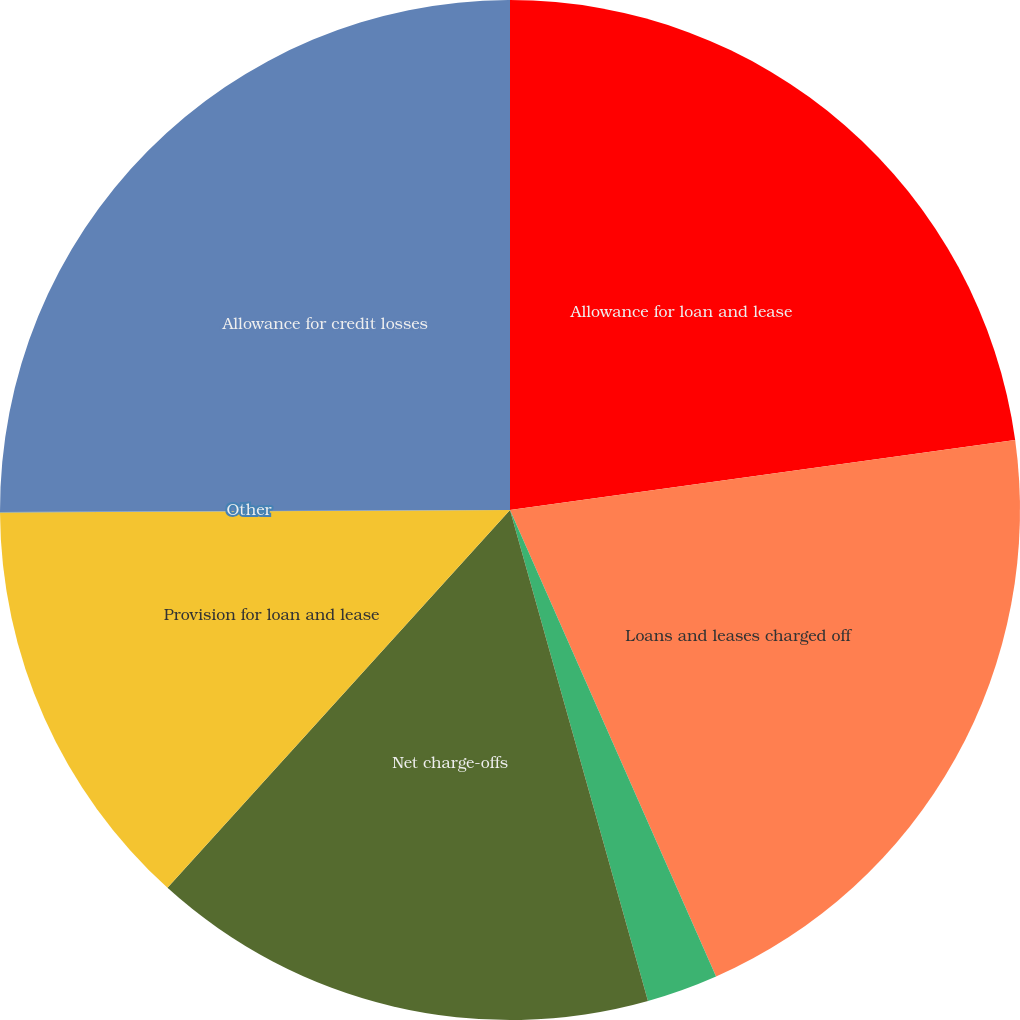Convert chart to OTSL. <chart><loc_0><loc_0><loc_500><loc_500><pie_chart><fcel>Allowance for loan and lease<fcel>Loans and leases charged off<fcel>Recoveries of loans and leases<fcel>Net charge-offs<fcel>Provision for loan and lease<fcel>Other<fcel>Allowance for credit losses<nl><fcel>22.81%<fcel>20.57%<fcel>2.26%<fcel>16.08%<fcel>13.2%<fcel>0.02%<fcel>25.06%<nl></chart> 